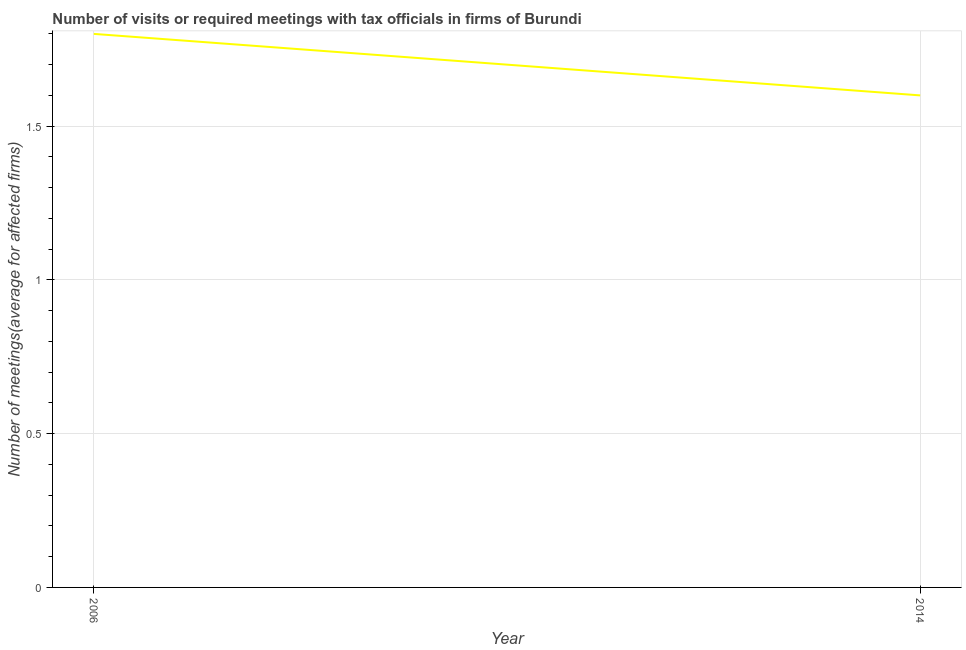Across all years, what is the maximum number of required meetings with tax officials?
Offer a very short reply. 1.8. What is the sum of the number of required meetings with tax officials?
Your answer should be compact. 3.4. What is the difference between the number of required meetings with tax officials in 2006 and 2014?
Your answer should be compact. 0.2. What is the average number of required meetings with tax officials per year?
Make the answer very short. 1.7. What is the median number of required meetings with tax officials?
Your response must be concise. 1.7. In how many years, is the number of required meetings with tax officials greater than 1.7 ?
Offer a terse response. 1. How many lines are there?
Provide a short and direct response. 1. What is the difference between two consecutive major ticks on the Y-axis?
Ensure brevity in your answer.  0.5. Does the graph contain any zero values?
Your response must be concise. No. What is the title of the graph?
Offer a terse response. Number of visits or required meetings with tax officials in firms of Burundi. What is the label or title of the Y-axis?
Offer a terse response. Number of meetings(average for affected firms). What is the Number of meetings(average for affected firms) in 2006?
Your answer should be very brief. 1.8. What is the Number of meetings(average for affected firms) in 2014?
Give a very brief answer. 1.6. What is the ratio of the Number of meetings(average for affected firms) in 2006 to that in 2014?
Provide a succinct answer. 1.12. 